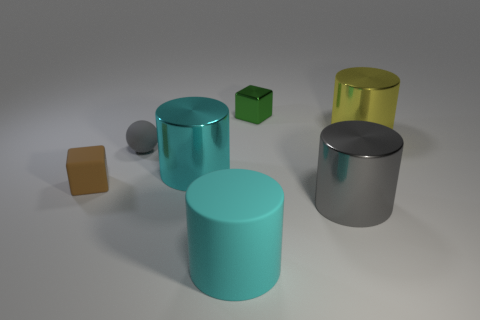Are there any large cyan metallic objects of the same shape as the gray metal thing?
Provide a short and direct response. Yes. What color is the rubber cube that is the same size as the gray matte thing?
Ensure brevity in your answer.  Brown. Is the number of small gray objects in front of the large gray cylinder less than the number of small brown cubes behind the tiny green cube?
Keep it short and to the point. No. There is a cylinder that is behind the sphere; is it the same size as the gray shiny cylinder?
Provide a succinct answer. Yes. There is a gray object to the left of the tiny green metallic block; what is its shape?
Provide a short and direct response. Sphere. Is the number of small blocks greater than the number of spheres?
Provide a short and direct response. Yes. Is the color of the metallic cylinder that is on the left side of the tiny green metallic thing the same as the large matte cylinder?
Keep it short and to the point. Yes. What number of objects are small cubes that are on the left side of the large cyan metallic cylinder or large cylinders that are behind the gray cylinder?
Provide a short and direct response. 3. What number of metal objects are both on the left side of the big gray metal cylinder and behind the small sphere?
Ensure brevity in your answer.  1. Is the material of the small gray thing the same as the small green block?
Ensure brevity in your answer.  No. 